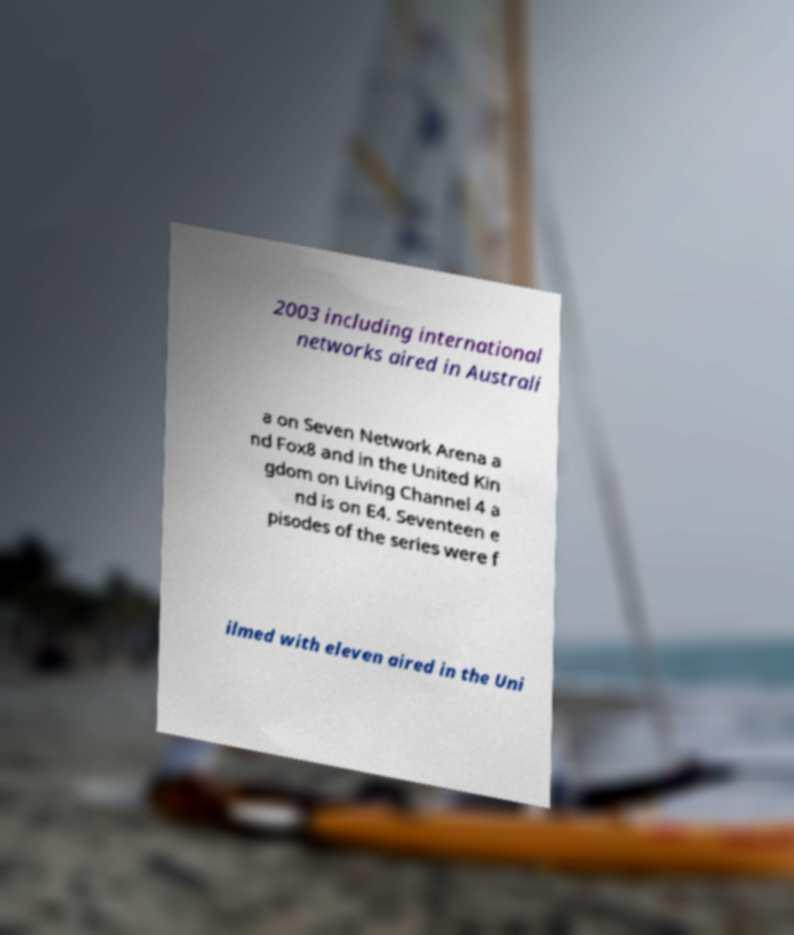Can you read and provide the text displayed in the image?This photo seems to have some interesting text. Can you extract and type it out for me? 2003 including international networks aired in Australi a on Seven Network Arena a nd Fox8 and in the United Kin gdom on Living Channel 4 a nd is on E4. Seventeen e pisodes of the series were f ilmed with eleven aired in the Uni 